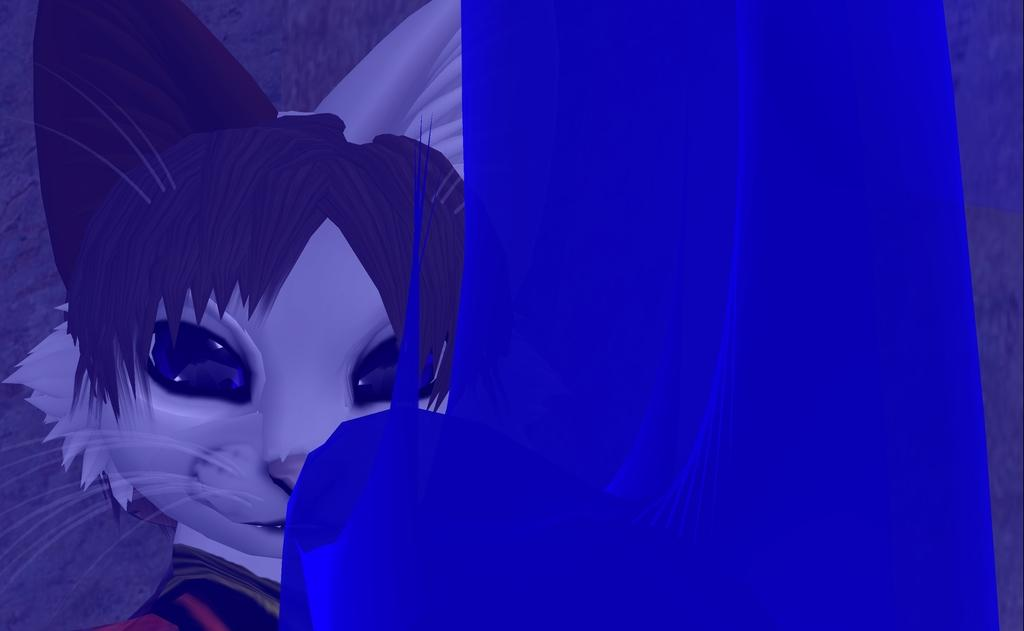What type of picture is the image? The image is an animated picture. What animal can be seen in the image? There is a cat in the image. What color is the cloth in the image? There is a blue cloth in the image. What type of twig is the cat holding in the image? There is no twig present in the image; it only features a cat and a blue cloth. 